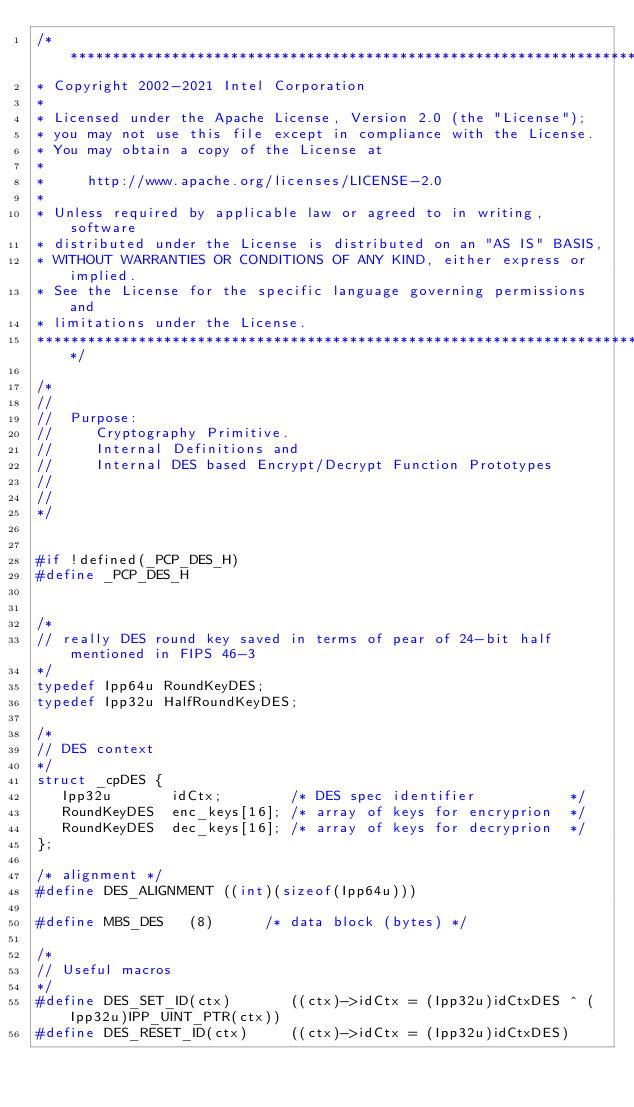<code> <loc_0><loc_0><loc_500><loc_500><_C_>/*******************************************************************************
* Copyright 2002-2021 Intel Corporation
*
* Licensed under the Apache License, Version 2.0 (the "License");
* you may not use this file except in compliance with the License.
* You may obtain a copy of the License at
*
*     http://www.apache.org/licenses/LICENSE-2.0
*
* Unless required by applicable law or agreed to in writing, software
* distributed under the License is distributed on an "AS IS" BASIS,
* WITHOUT WARRANTIES OR CONDITIONS OF ANY KIND, either express or implied.
* See the License for the specific language governing permissions and
* limitations under the License.
*******************************************************************************/

/* 
// 
//  Purpose:
//     Cryptography Primitive.
//     Internal Definitions and
//     Internal DES based Encrypt/Decrypt Function Prototypes
// 
// 
*/


#if !defined(_PCP_DES_H)
#define _PCP_DES_H


/*
// really DES round key saved in terms of pear of 24-bit half mentioned in FIPS 46-3
*/
typedef Ipp64u RoundKeyDES;
typedef Ipp32u HalfRoundKeyDES;

/*
// DES context
*/
struct _cpDES {
   Ipp32u       idCtx;        /* DES spec identifier           */
   RoundKeyDES  enc_keys[16]; /* array of keys for encryprion  */
   RoundKeyDES  dec_keys[16]; /* array of keys for decryprion  */
};

/* alignment */
#define DES_ALIGNMENT ((int)(sizeof(Ipp64u)))

#define MBS_DES   (8)      /* data block (bytes) */

/*
// Useful macros
*/
#define DES_SET_ID(ctx)       ((ctx)->idCtx = (Ipp32u)idCtxDES ^ (Ipp32u)IPP_UINT_PTR(ctx))
#define DES_RESET_ID(ctx)     ((ctx)->idCtx = (Ipp32u)idCtxDES)</code> 